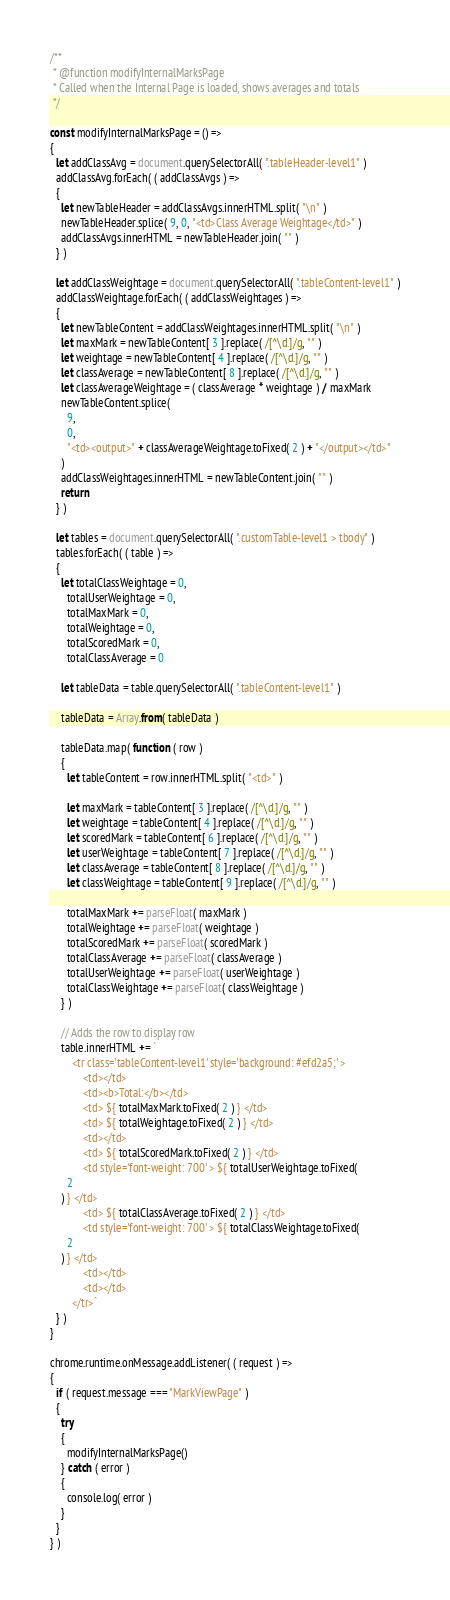Convert code to text. <code><loc_0><loc_0><loc_500><loc_500><_JavaScript_>/**
 * @function modifyInternalMarksPage
 * Called when the Internal Page is loaded, shows averages and totals
 */

const modifyInternalMarksPage = () =>
{
  let addClassAvg = document.querySelectorAll( ".tableHeader-level1" )
  addClassAvg.forEach( ( addClassAvgs ) =>
  {
    let newTableHeader = addClassAvgs.innerHTML.split( "\n" )
    newTableHeader.splice( 9, 0, "<td>Class Average Weightage</td>" )
    addClassAvgs.innerHTML = newTableHeader.join( "" )
  } )

  let addClassWeightage = document.querySelectorAll( ".tableContent-level1" )
  addClassWeightage.forEach( ( addClassWeightages ) =>
  {
    let newTableContent = addClassWeightages.innerHTML.split( "\n" )
    let maxMark = newTableContent[ 3 ].replace( /[^\d.]/g, "" )
    let weightage = newTableContent[ 4 ].replace( /[^\d.]/g, "" )
    let classAverage = newTableContent[ 8 ].replace( /[^\d.]/g, "" )
    let classAverageWeightage = ( classAverage * weightage ) / maxMark
    newTableContent.splice(
      9,
      0,
      "<td><output>" + classAverageWeightage.toFixed( 2 ) + "</output></td>"
    )
    addClassWeightages.innerHTML = newTableContent.join( "" )
    return
  } )

  let tables = document.querySelectorAll( ".customTable-level1 > tbody" )
  tables.forEach( ( table ) =>
  {
    let totalClassWeightage = 0,
      totalUserWeightage = 0,
      totalMaxMark = 0,
      totalWeightage = 0,
      totalScoredMark = 0,
      totalClassAverage = 0

    let tableData = table.querySelectorAll( ".tableContent-level1" )

    tableData = Array.from( tableData )

    tableData.map( function ( row )
    {
      let tableContent = row.innerHTML.split( "<td>" )

      let maxMark = tableContent[ 3 ].replace( /[^\d.]/g, "" )
      let weightage = tableContent[ 4 ].replace( /[^\d.]/g, "" )
      let scoredMark = tableContent[ 6 ].replace( /[^\d.]/g, "" )
      let userWeightage = tableContent[ 7 ].replace( /[^\d.]/g, "" )
      let classAverage = tableContent[ 8 ].replace( /[^\d.]/g, "" )
      let classWeightage = tableContent[ 9 ].replace( /[^\d.]/g, "" )

      totalMaxMark += parseFloat( maxMark )
      totalWeightage += parseFloat( weightage )
      totalScoredMark += parseFloat( scoredMark )
      totalClassAverage += parseFloat( classAverage )
      totalUserWeightage += parseFloat( userWeightage )
      totalClassWeightage += parseFloat( classWeightage )
    } )

    // Adds the row to display row
    table.innerHTML += `
        <tr class='tableContent-level1' style='background: #efd2a5;' >
            <td></td>
            <td><b>Total:</b></td>
            <td> ${ totalMaxMark.toFixed( 2 ) } </td>
            <td> ${ totalWeightage.toFixed( 2 ) } </td>
            <td></td>
            <td> ${ totalScoredMark.toFixed( 2 ) } </td>
            <td style='font-weight: 700' > ${ totalUserWeightage.toFixed(
      2
    ) } </td>
            <td> ${ totalClassAverage.toFixed( 2 ) } </td>
            <td style='font-weight: 700' > ${ totalClassWeightage.toFixed(
      2
    ) } </td>
            <td></td>
            <td></td>
        </tr>`
  } )
}

chrome.runtime.onMessage.addListener( ( request ) =>
{
  if ( request.message === "MarkViewPage" )
  {
    try
    {
      modifyInternalMarksPage()
    } catch ( error )
    {
      console.log( error )
    }
  }
} )
</code> 